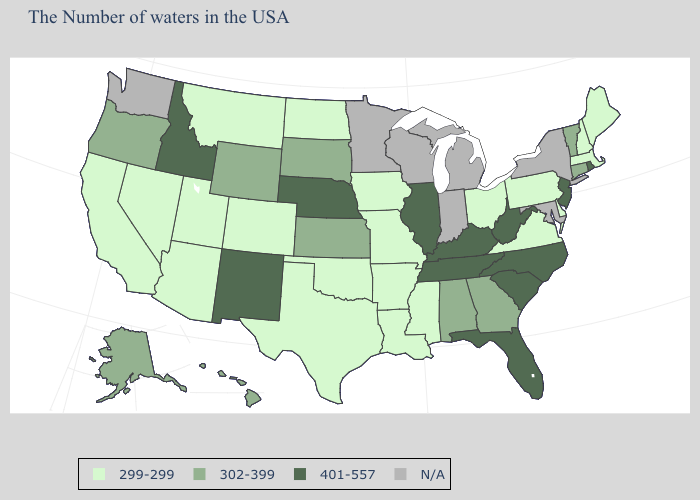Among the states that border New Hampshire , which have the lowest value?
Concise answer only. Maine, Massachusetts. Does the first symbol in the legend represent the smallest category?
Write a very short answer. Yes. What is the value of Mississippi?
Keep it brief. 299-299. What is the highest value in the West ?
Be succinct. 401-557. Does New Hampshire have the lowest value in the Northeast?
Be succinct. Yes. What is the value of Vermont?
Write a very short answer. 302-399. Which states have the lowest value in the Northeast?
Give a very brief answer. Maine, Massachusetts, New Hampshire, Pennsylvania. Among the states that border Minnesota , does South Dakota have the lowest value?
Keep it brief. No. Name the states that have a value in the range 302-399?
Be succinct. Vermont, Connecticut, Georgia, Alabama, Kansas, South Dakota, Wyoming, Oregon, Alaska, Hawaii. Name the states that have a value in the range 302-399?
Write a very short answer. Vermont, Connecticut, Georgia, Alabama, Kansas, South Dakota, Wyoming, Oregon, Alaska, Hawaii. Name the states that have a value in the range 302-399?
Short answer required. Vermont, Connecticut, Georgia, Alabama, Kansas, South Dakota, Wyoming, Oregon, Alaska, Hawaii. What is the value of Alaska?
Quick response, please. 302-399. How many symbols are there in the legend?
Be succinct. 4. 